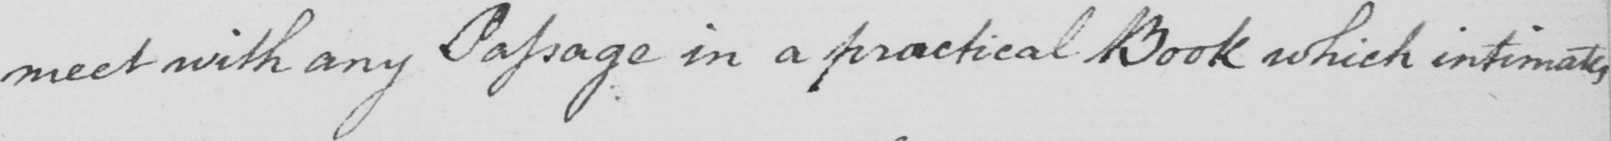Can you tell me what this handwritten text says? meet with any Passage in a practical Book which intimates 